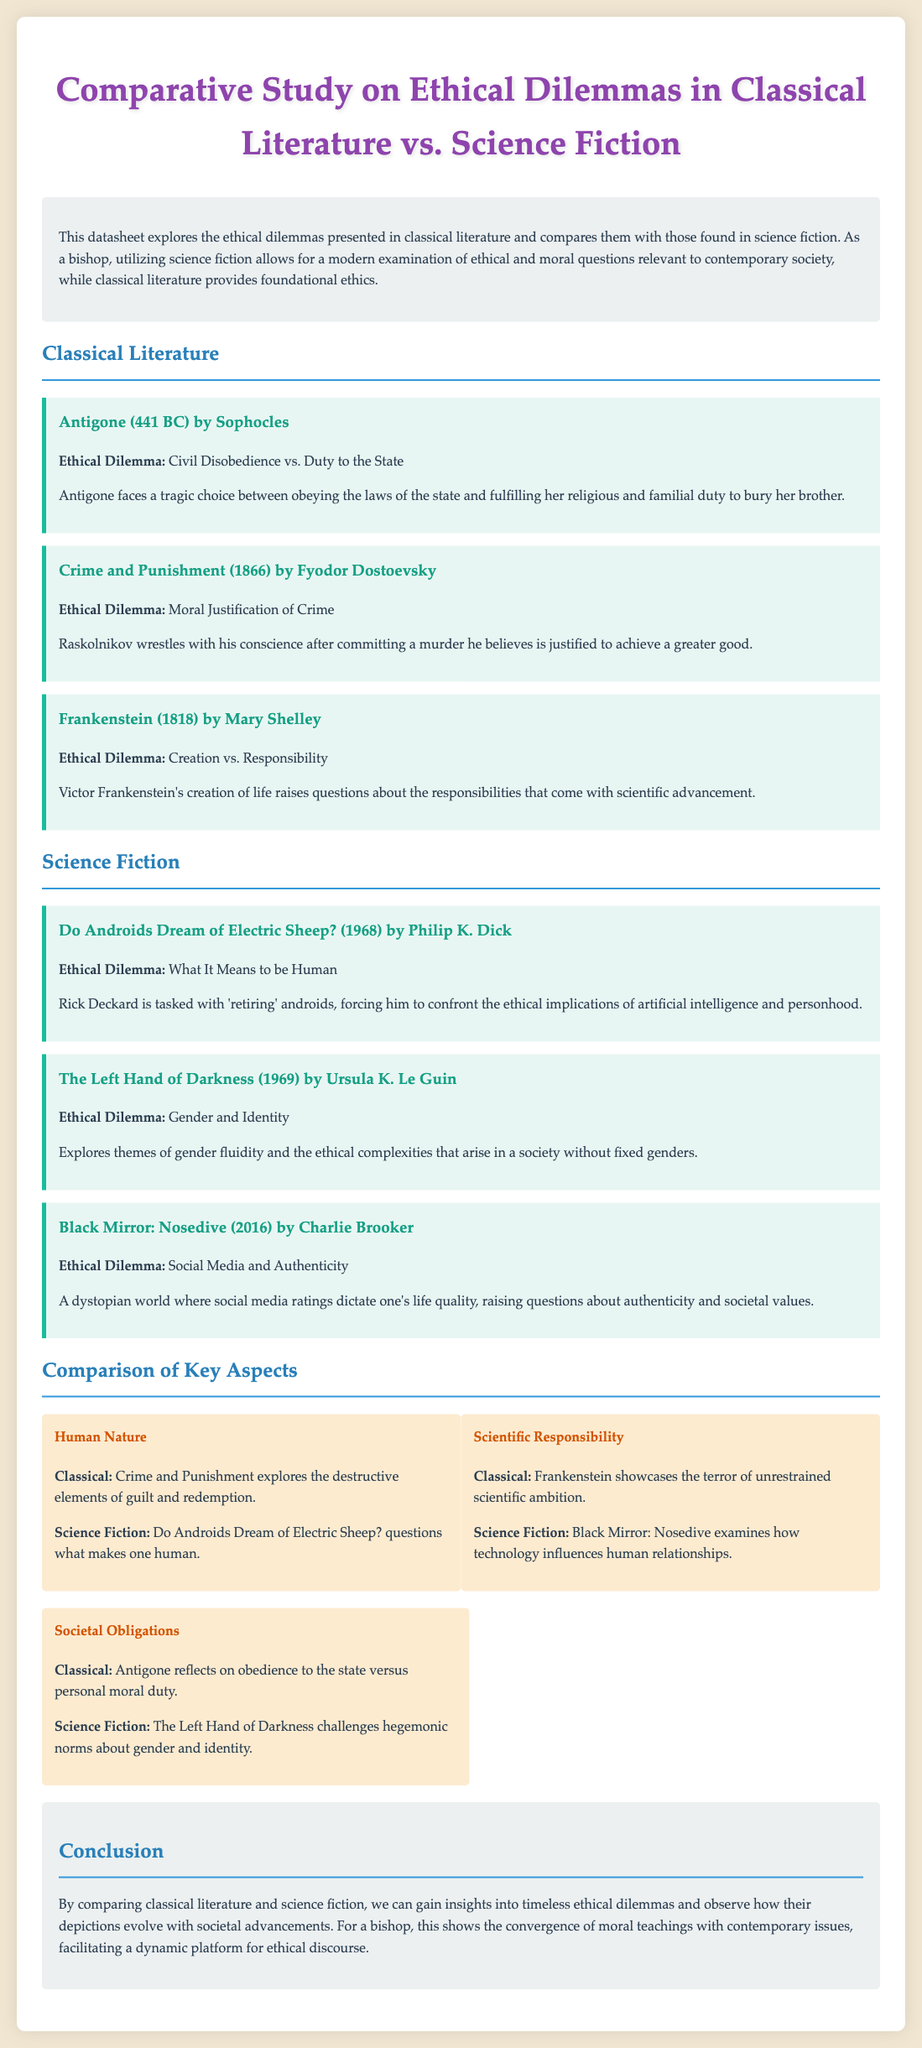what is the title of the datasheet? The title is prominently displayed at the beginning of the document.
Answer: Comparative Study on Ethical Dilemmas in Classical Literature vs. Science Fiction who is the author of "Crime and Punishment"? The author is listed for each work featured in the document.
Answer: Fyodor Dostoevsky what ethical dilemma does "Antigone" present? The document specifies the ethical dilemmas associated with each literary piece.
Answer: Civil Disobedience vs. Duty to the State which science fiction work questions the meaning of being human? The ethical dilemmas section identifies key themes for each work.
Answer: Do Androids Dream of Electric Sheep? what is the key theme of the comparison regarding societal obligations? The document outlines various comparisons, detailing the key aspects for classical literature and science fiction.
Answer: Obedience to the state vs. personal moral duty who wrote "The Left Hand of Darkness"? The authorship is noted for science fiction works included in the datasheet.
Answer: Ursula K. Le Guin what year was "Frankenstein" published? The publication year is mentioned in the context of the classical works discussed.
Answer: 1818 what ethical dilemma is explored in "Black Mirror: Nosedive"? Each work is associated with its respective ethical dilemma in the document.
Answer: Social Media and Authenticity how many science fiction works are presented in the datasheet? The document lists the number of works under the science fiction section.
Answer: Three 